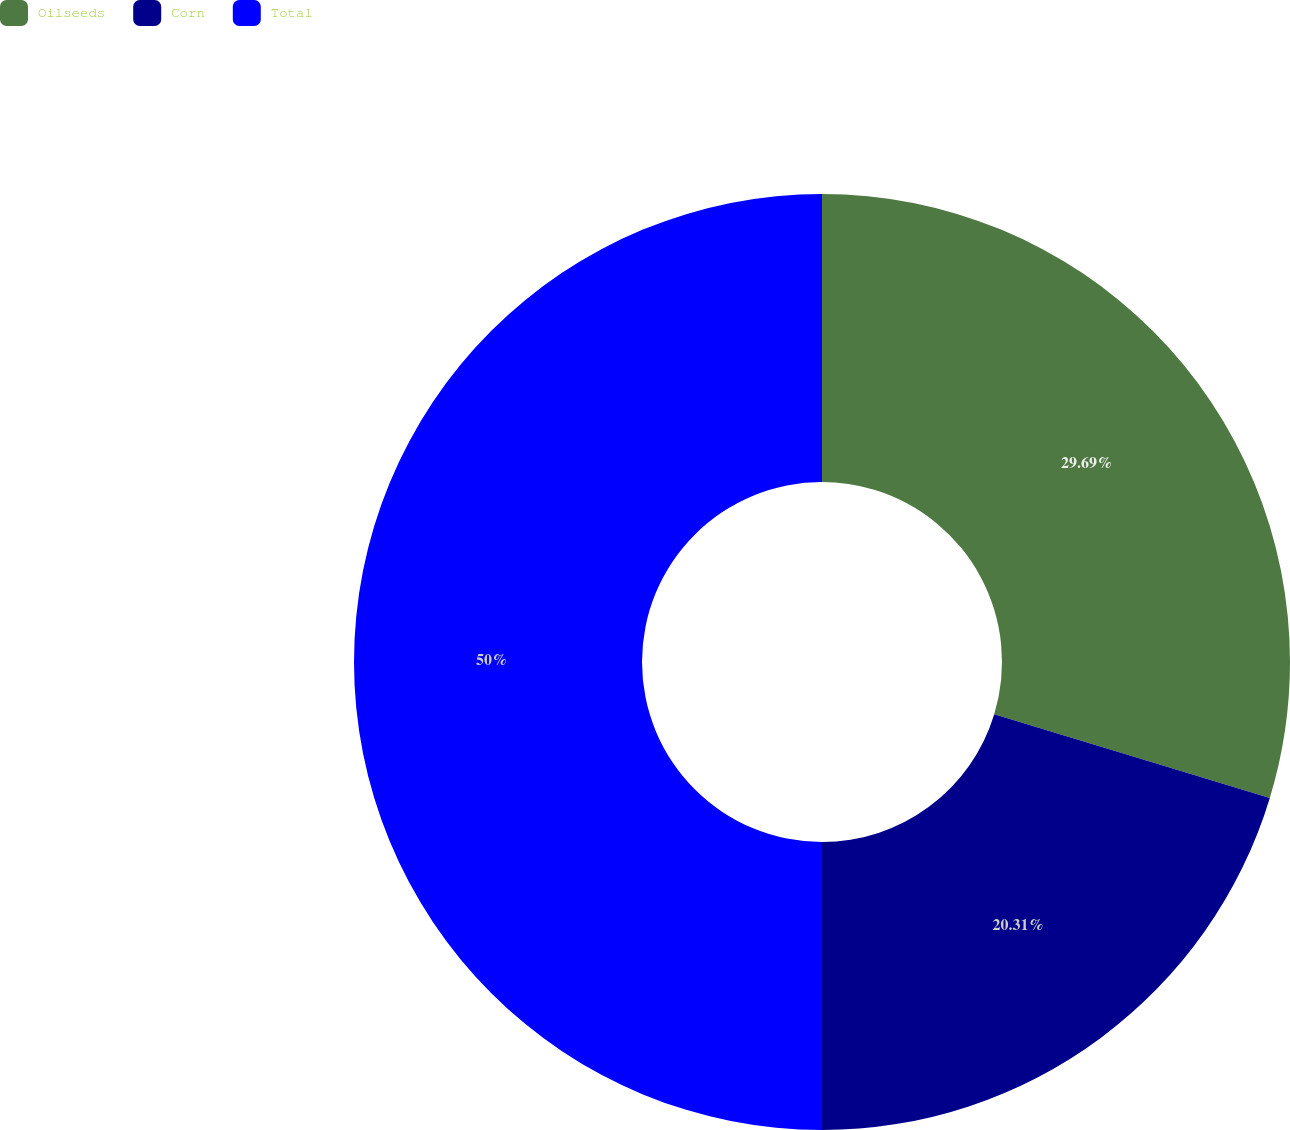<chart> <loc_0><loc_0><loc_500><loc_500><pie_chart><fcel>Oilseeds<fcel>Corn<fcel>Total<nl><fcel>29.69%<fcel>20.31%<fcel>50.0%<nl></chart> 